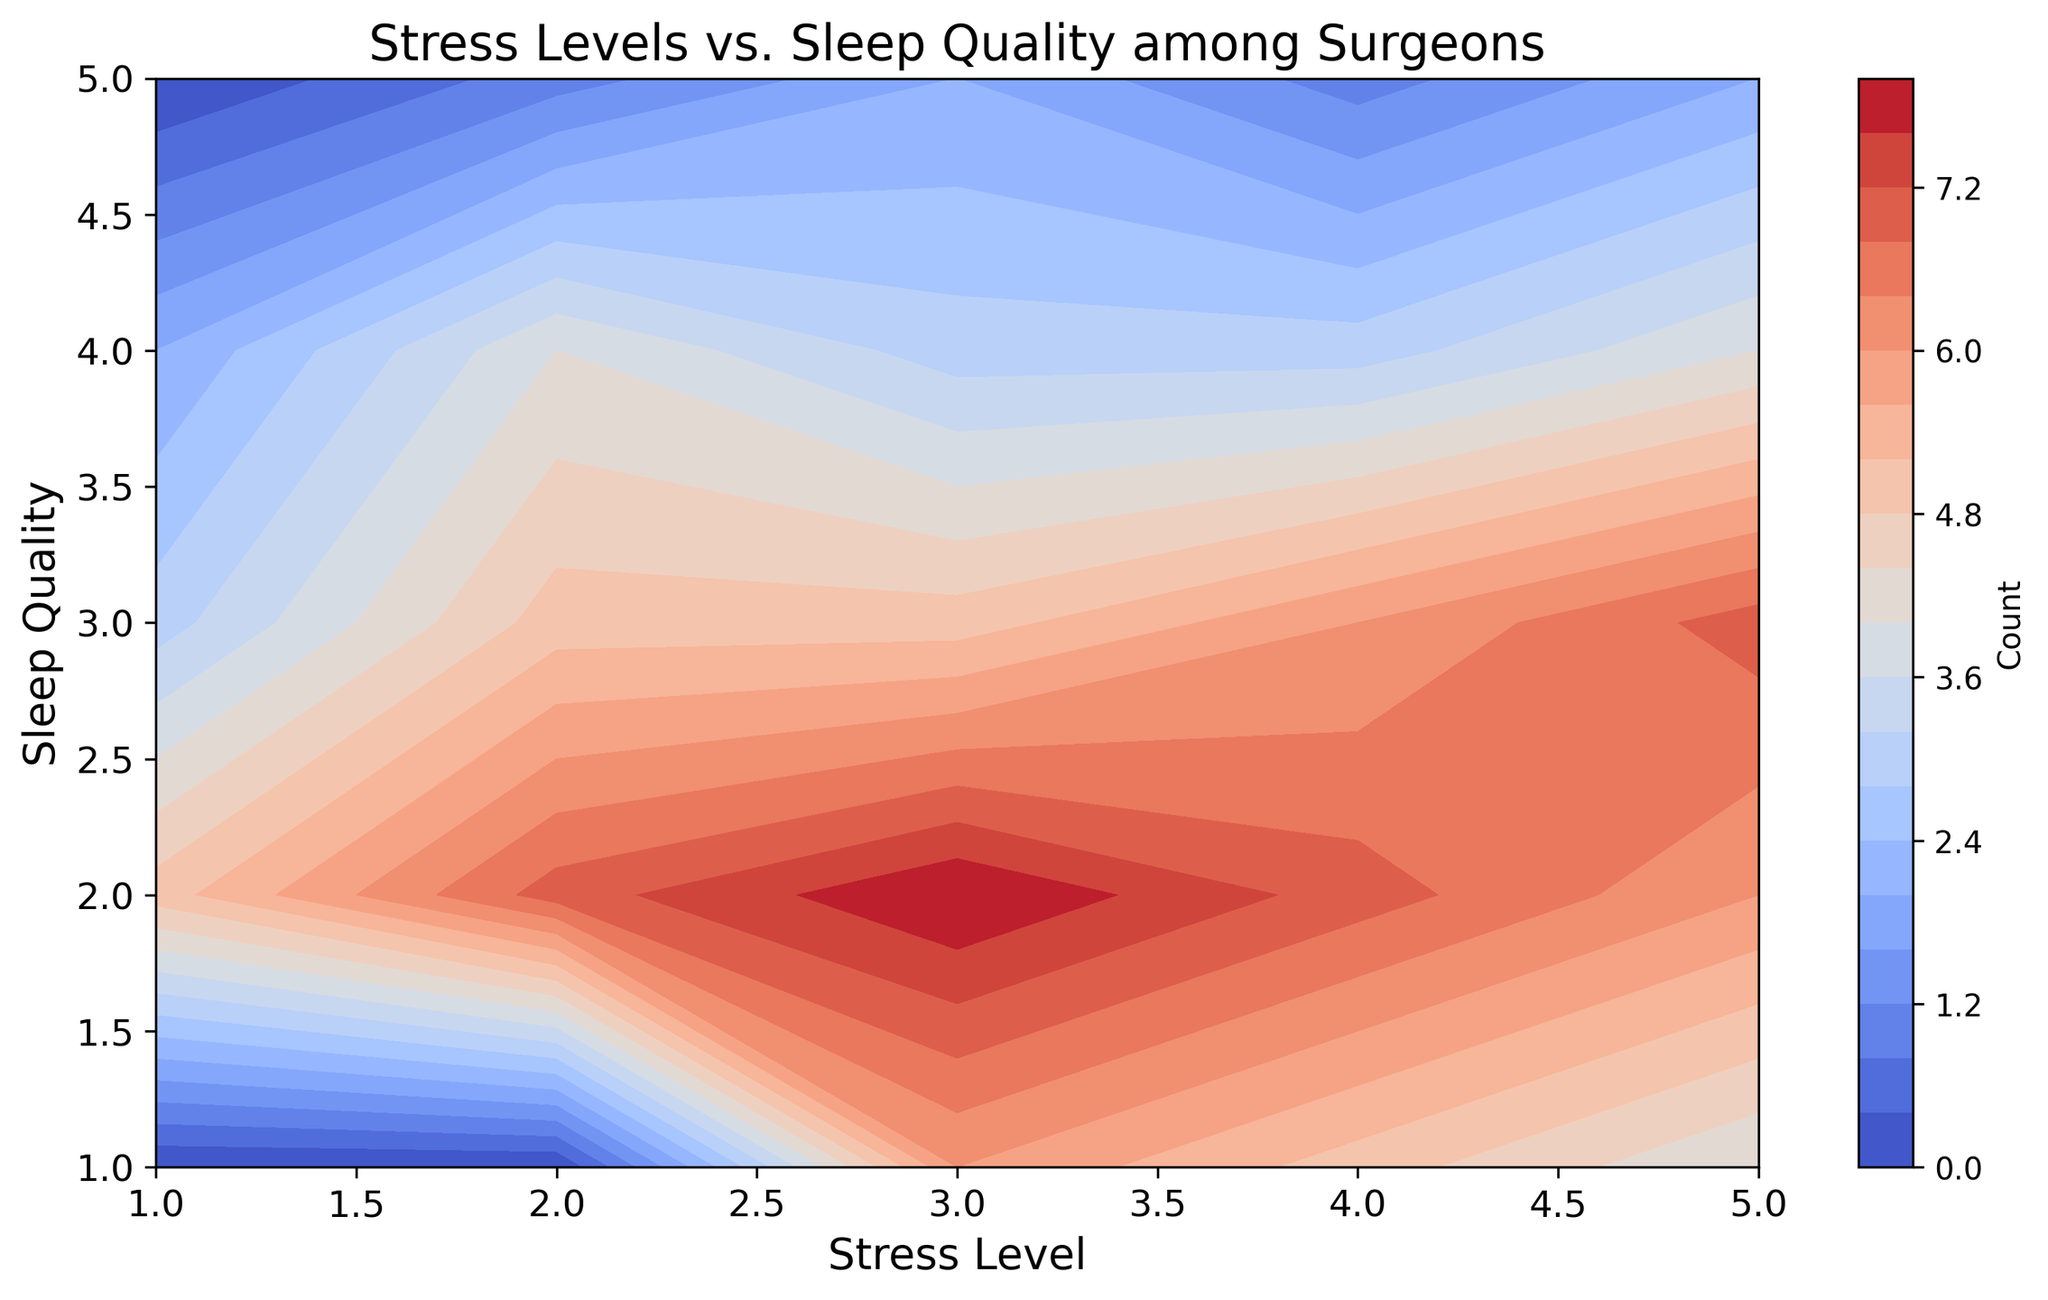How does sleep quality affect the stress level among surgeons? Looking at the contour plot, regions of higher counts are seen where sleep quality is 3 and stress levels range from 2 to 5. This suggests that when sleep quality improves, stress level decreases among surgeons.
Answer: As sleep quality increases, stress levels generally decrease At which stress level is the sleep quality of 3 most commonly observed? Observing the contour plot, the highest counts on the sleep quality level of 3 occur at stress levels 2 and 5, but the higher value is for stress level 5.
Answer: 5 Which sleep quality and stress level combination has the highest count? The darkest (redder) area indicates the highest count. This appears to be at sleep quality 2 and stress level 3.
Answer: Sleep quality 2 and stress level 3 Comparing stress levels 1 and 4, does the sleep quality of 2 have higher counts in both cases? Refer to the contour shades at stress levels 1 and 4 for sleep quality of 2. For stress level 1, the count is less intense compared to stress level 4. Thus, the count is higher at stress level 4 for sleep quality 2.
Answer: No, stress level 4 has a higher count What is the sum of counts for stress levels 3 and 4 at sleep quality 1? Using the contour plot, find and sum the counts at sleep quality 1 for stress levels 3 and 4. The count for stress level 3 is 6 and for stress level 4 is 5. The total is 6 + 5.
Answer: 11 How does the count vary as we move from a stress level of 2 to 5 at a sleep quality of 4? Examine the contour shades at sleep quality 4 for stress levels 2, 3, 4, and 5. The counts decrease progressively from 4 to 2.
Answer: The count decreases from 4 to 2 Is sleep quality of 1 more common at stress level 4 or stress level 5? Check the plot for sleep quality 1 at stress levels 4 and 5. The contour for stress level 4 is darker than for stress level 5.
Answer: Stress level 4 What combination of stress level and sleep quality has the least count? The lightest shades indicating the lowest counts are observed at stress levels 1 and 2 for sleep quality 5. Since these are equally light, we look for specific values.
Answer: Stress level 2, sleep quality 5 Comparing sleep quality 2 and 3, which one has a broader range of stress levels with higher counts? Check the contour plot for both sleep quality levels across stress levels 1 to 5. Sleep quality 2 has higher intensities across more stress levels compared to sleep quality 3.
Answer: Sleep quality 2 